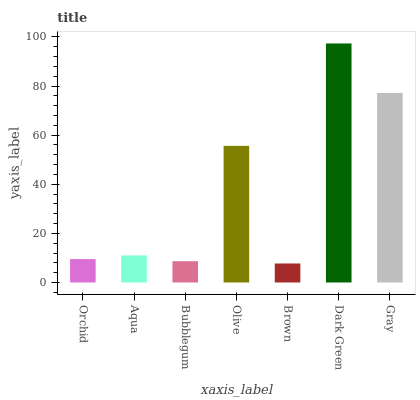Is Brown the minimum?
Answer yes or no. Yes. Is Dark Green the maximum?
Answer yes or no. Yes. Is Aqua the minimum?
Answer yes or no. No. Is Aqua the maximum?
Answer yes or no. No. Is Aqua greater than Orchid?
Answer yes or no. Yes. Is Orchid less than Aqua?
Answer yes or no. Yes. Is Orchid greater than Aqua?
Answer yes or no. No. Is Aqua less than Orchid?
Answer yes or no. No. Is Aqua the high median?
Answer yes or no. Yes. Is Aqua the low median?
Answer yes or no. Yes. Is Bubblegum the high median?
Answer yes or no. No. Is Gray the low median?
Answer yes or no. No. 